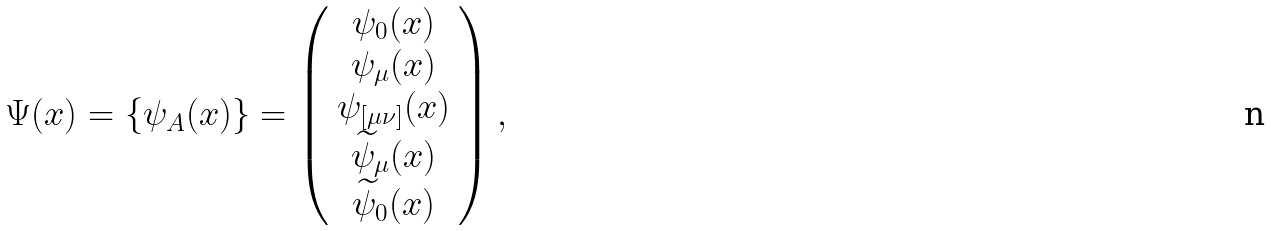Convert formula to latex. <formula><loc_0><loc_0><loc_500><loc_500>\Psi ( x ) = \left \{ \psi _ { A } ( x ) \right \} = \left ( \begin{array} { c } \psi _ { 0 } ( x ) \\ \psi _ { \mu } ( x ) \\ \psi _ { [ \mu \nu ] } ( x ) \\ \widetilde { \psi } _ { \mu } ( x ) \\ \widetilde { \psi } _ { 0 } ( x ) \end{array} \right ) ,</formula> 